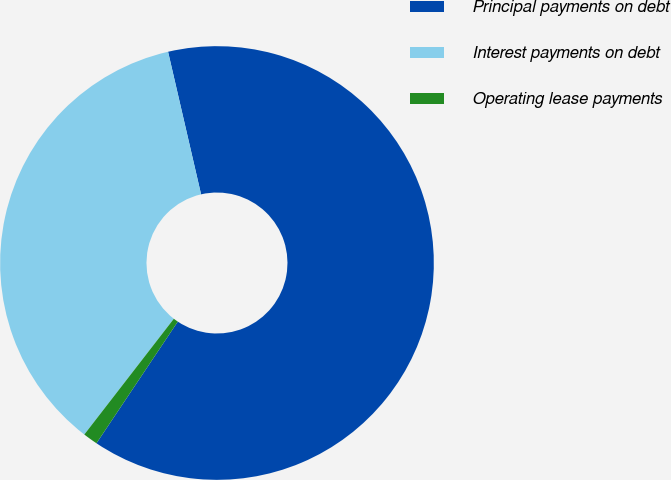Convert chart to OTSL. <chart><loc_0><loc_0><loc_500><loc_500><pie_chart><fcel>Principal payments on debt<fcel>Interest payments on debt<fcel>Operating lease payments<nl><fcel>63.0%<fcel>35.9%<fcel>1.1%<nl></chart> 